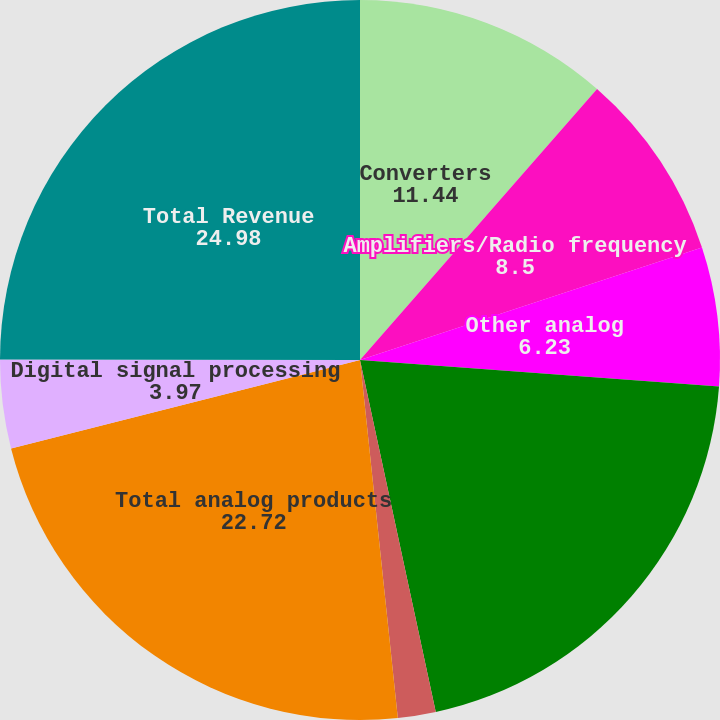Convert chart to OTSL. <chart><loc_0><loc_0><loc_500><loc_500><pie_chart><fcel>Converters<fcel>Amplifiers/Radio frequency<fcel>Other analog<fcel>Subtotal analog signal<fcel>Power management & reference<fcel>Total analog products<fcel>Digital signal processing<fcel>Total Revenue<nl><fcel>11.44%<fcel>8.5%<fcel>6.23%<fcel>20.45%<fcel>1.7%<fcel>22.72%<fcel>3.97%<fcel>24.98%<nl></chart> 